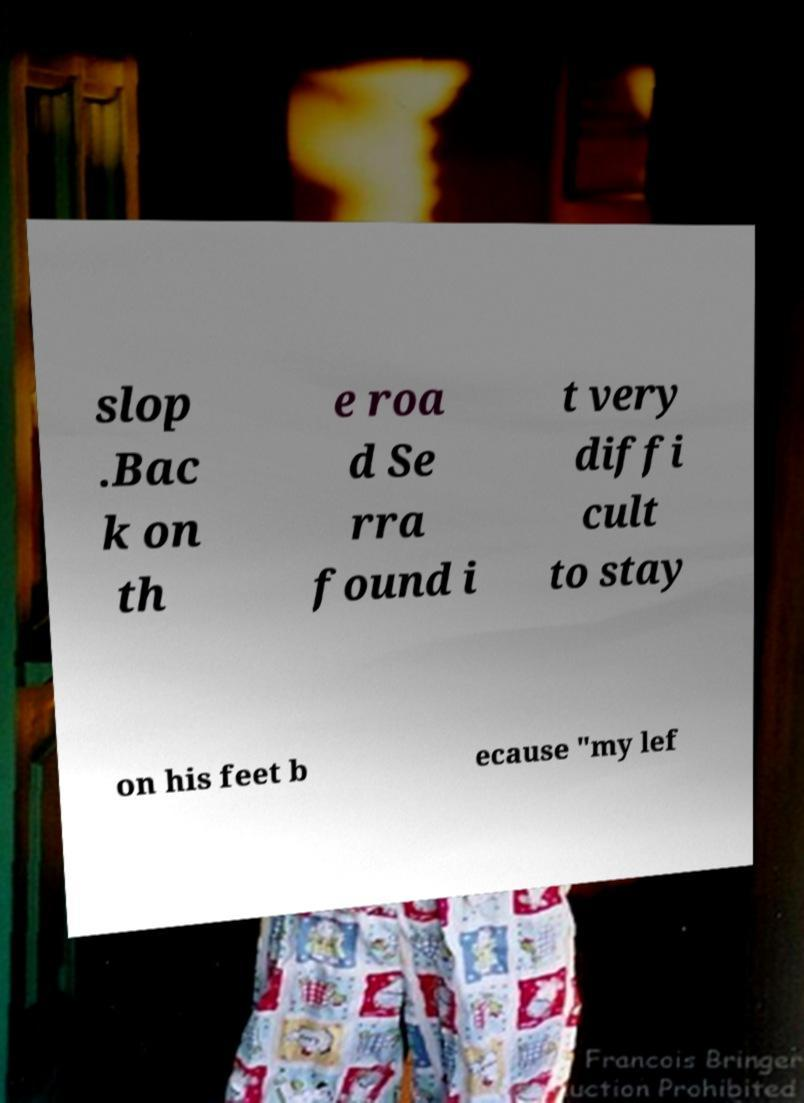Please identify and transcribe the text found in this image. slop .Bac k on th e roa d Se rra found i t very diffi cult to stay on his feet b ecause "my lef 